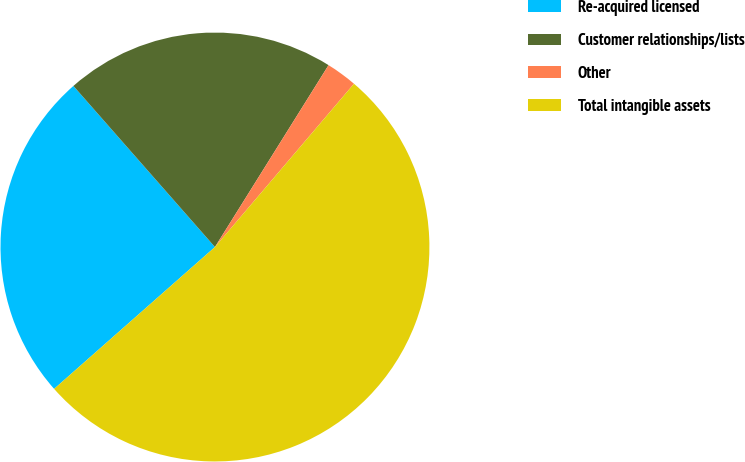<chart> <loc_0><loc_0><loc_500><loc_500><pie_chart><fcel>Re-acquired licensed<fcel>Customer relationships/lists<fcel>Other<fcel>Total intangible assets<nl><fcel>25.03%<fcel>20.36%<fcel>2.34%<fcel>52.27%<nl></chart> 